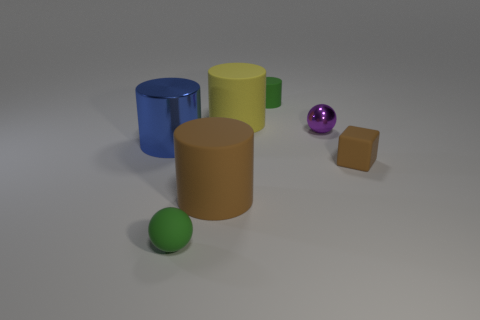There is a rubber block; does it have the same color as the large matte cylinder on the left side of the yellow matte cylinder? yes 